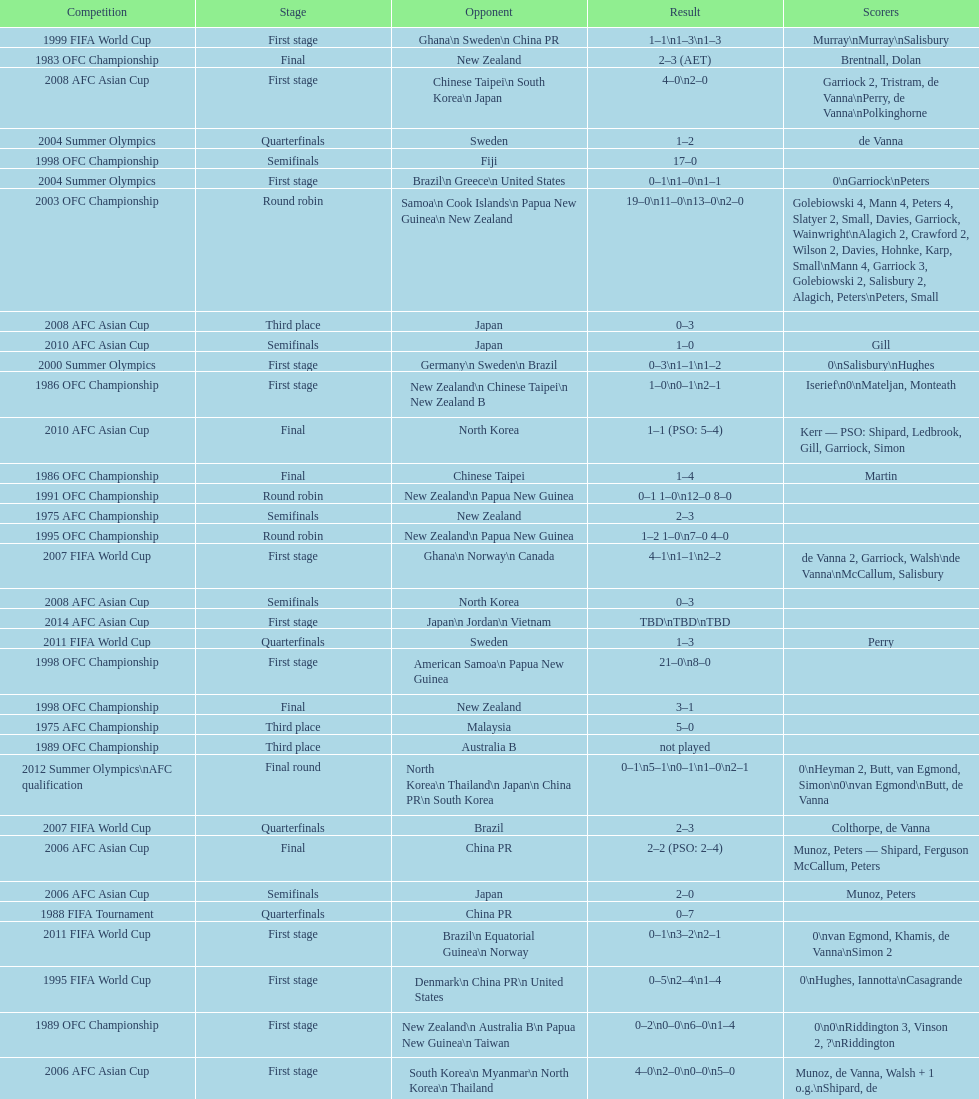Who scored better in the 1995 fifa world cup denmark or the united states? United States. 